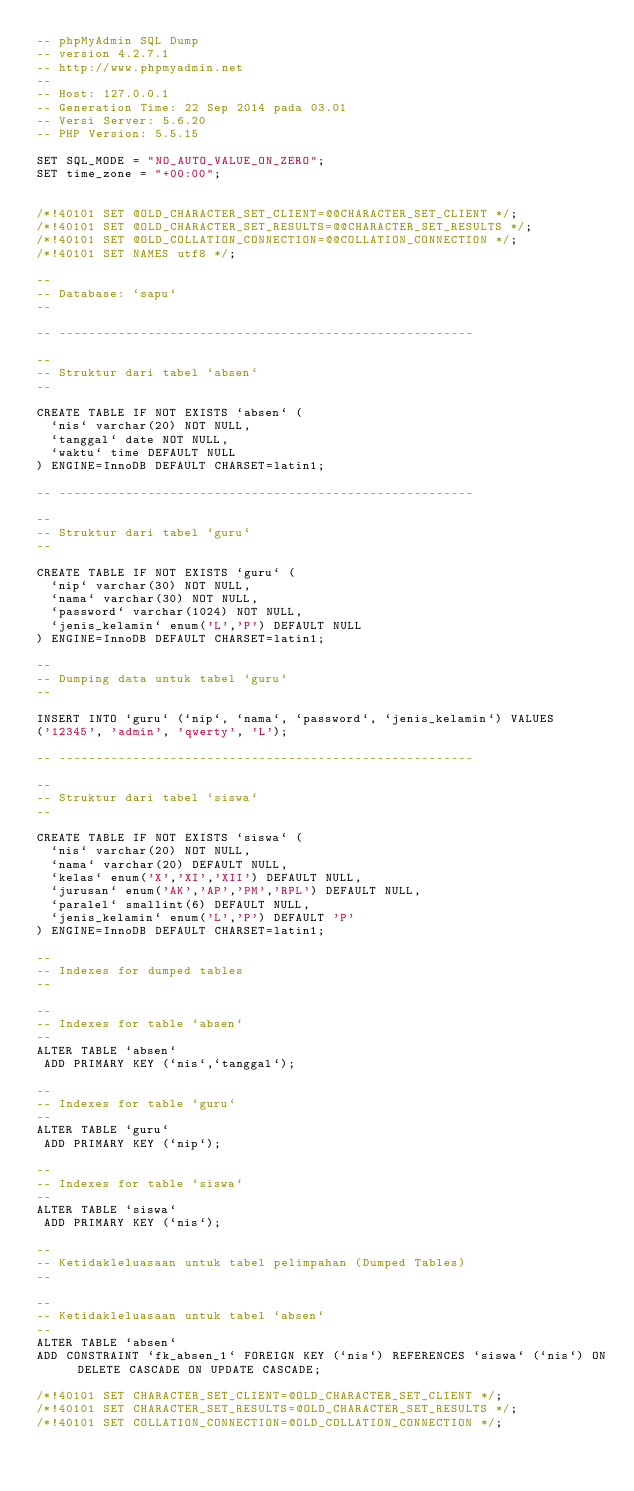Convert code to text. <code><loc_0><loc_0><loc_500><loc_500><_SQL_>-- phpMyAdmin SQL Dump
-- version 4.2.7.1
-- http://www.phpmyadmin.net
--
-- Host: 127.0.0.1
-- Generation Time: 22 Sep 2014 pada 03.01
-- Versi Server: 5.6.20
-- PHP Version: 5.5.15

SET SQL_MODE = "NO_AUTO_VALUE_ON_ZERO";
SET time_zone = "+00:00";


/*!40101 SET @OLD_CHARACTER_SET_CLIENT=@@CHARACTER_SET_CLIENT */;
/*!40101 SET @OLD_CHARACTER_SET_RESULTS=@@CHARACTER_SET_RESULTS */;
/*!40101 SET @OLD_COLLATION_CONNECTION=@@COLLATION_CONNECTION */;
/*!40101 SET NAMES utf8 */;

--
-- Database: `sapu`
--

-- --------------------------------------------------------

--
-- Struktur dari tabel `absen`
--

CREATE TABLE IF NOT EXISTS `absen` (
  `nis` varchar(20) NOT NULL,
  `tanggal` date NOT NULL,
  `waktu` time DEFAULT NULL
) ENGINE=InnoDB DEFAULT CHARSET=latin1;

-- --------------------------------------------------------

--
-- Struktur dari tabel `guru`
--

CREATE TABLE IF NOT EXISTS `guru` (
  `nip` varchar(30) NOT NULL,
  `nama` varchar(30) NOT NULL,
  `password` varchar(1024) NOT NULL,
  `jenis_kelamin` enum('L','P') DEFAULT NULL
) ENGINE=InnoDB DEFAULT CHARSET=latin1;

--
-- Dumping data untuk tabel `guru`
--

INSERT INTO `guru` (`nip`, `nama`, `password`, `jenis_kelamin`) VALUES
('12345', 'admin', 'qwerty', 'L');

-- --------------------------------------------------------

--
-- Struktur dari tabel `siswa`
--

CREATE TABLE IF NOT EXISTS `siswa` (
  `nis` varchar(20) NOT NULL,
  `nama` varchar(20) DEFAULT NULL,
  `kelas` enum('X','XI','XII') DEFAULT NULL,
  `jurusan` enum('AK','AP','PM','RPL') DEFAULT NULL,
  `paralel` smallint(6) DEFAULT NULL,
  `jenis_kelamin` enum('L','P') DEFAULT 'P'
) ENGINE=InnoDB DEFAULT CHARSET=latin1;

--
-- Indexes for dumped tables
--

--
-- Indexes for table `absen`
--
ALTER TABLE `absen`
 ADD PRIMARY KEY (`nis`,`tanggal`);

--
-- Indexes for table `guru`
--
ALTER TABLE `guru`
 ADD PRIMARY KEY (`nip`);

--
-- Indexes for table `siswa`
--
ALTER TABLE `siswa`
 ADD PRIMARY KEY (`nis`);

--
-- Ketidakleluasaan untuk tabel pelimpahan (Dumped Tables)
--

--
-- Ketidakleluasaan untuk tabel `absen`
--
ALTER TABLE `absen`
ADD CONSTRAINT `fk_absen_1` FOREIGN KEY (`nis`) REFERENCES `siswa` (`nis`) ON DELETE CASCADE ON UPDATE CASCADE;

/*!40101 SET CHARACTER_SET_CLIENT=@OLD_CHARACTER_SET_CLIENT */;
/*!40101 SET CHARACTER_SET_RESULTS=@OLD_CHARACTER_SET_RESULTS */;
/*!40101 SET COLLATION_CONNECTION=@OLD_COLLATION_CONNECTION */;
</code> 